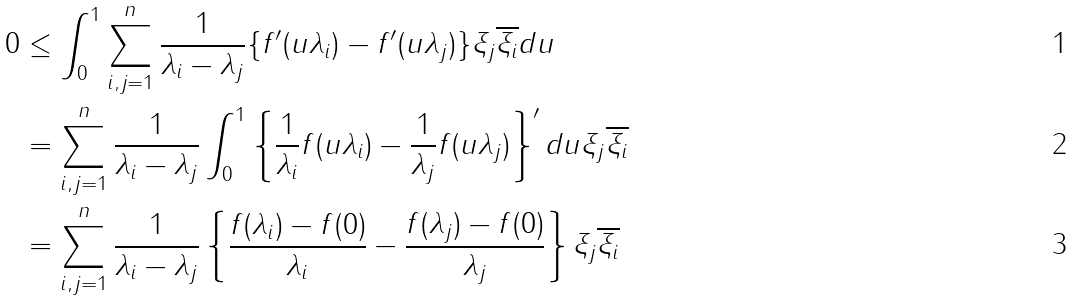<formula> <loc_0><loc_0><loc_500><loc_500>0 & \leq \int _ { 0 } ^ { 1 } \sum _ { i , j = 1 } ^ { n } \frac { 1 } { \lambda _ { i } - \lambda _ { j } } \{ f ^ { \prime } ( u \lambda _ { i } ) - f ^ { \prime } ( u \lambda _ { j } ) \} \xi _ { j } \overline { \xi _ { i } } d u \\ & = \sum _ { i , j = 1 } ^ { n } \frac { 1 } { \lambda _ { i } - \lambda _ { j } } \int _ { 0 } ^ { 1 } \left \{ \frac { 1 } { \lambda _ { i } } f ( u \lambda _ { i } ) - \frac { 1 } { \lambda _ { j } } f ( u \lambda _ { j } ) \right \} ^ { \prime } d u \xi _ { j } \overline { \xi _ { i } } \\ & = \sum _ { i , j = 1 } ^ { n } \frac { 1 } { \lambda _ { i } - \lambda _ { j } } \left \{ \frac { f ( \lambda _ { i } ) - f ( 0 ) } { \lambda _ { i } } - \frac { f ( \lambda _ { j } ) - f ( 0 ) } { \lambda _ { j } } \right \} \xi _ { j } \overline { \xi _ { i } }</formula> 